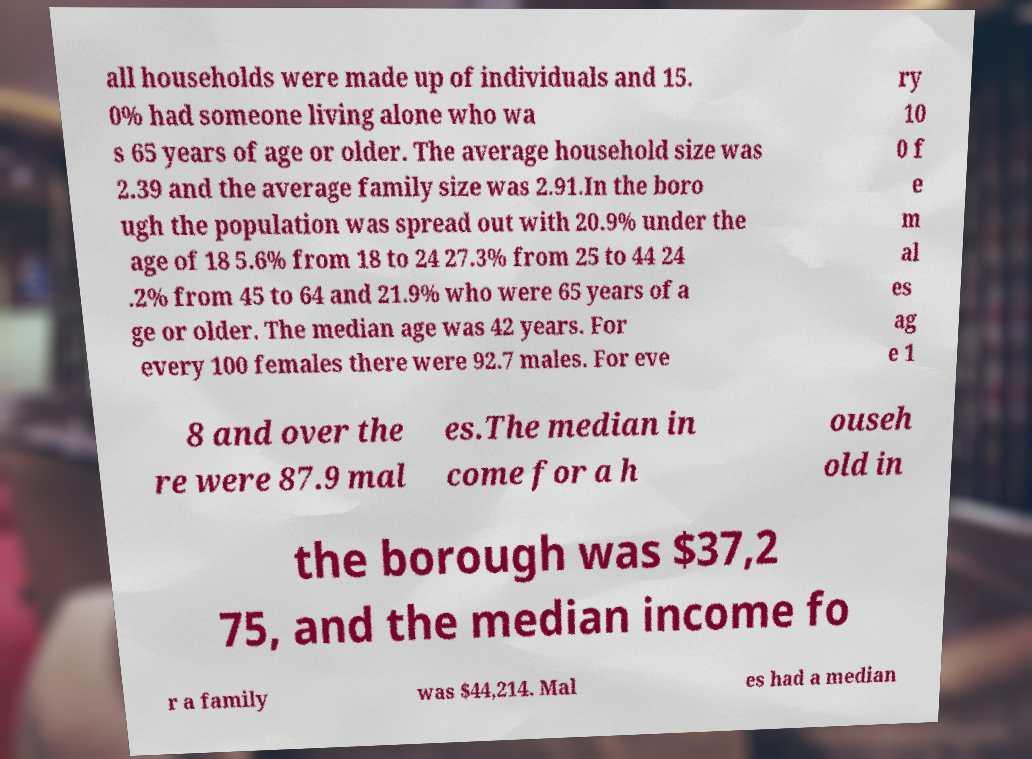Please read and relay the text visible in this image. What does it say? all households were made up of individuals and 15. 0% had someone living alone who wa s 65 years of age or older. The average household size was 2.39 and the average family size was 2.91.In the boro ugh the population was spread out with 20.9% under the age of 18 5.6% from 18 to 24 27.3% from 25 to 44 24 .2% from 45 to 64 and 21.9% who were 65 years of a ge or older. The median age was 42 years. For every 100 females there were 92.7 males. For eve ry 10 0 f e m al es ag e 1 8 and over the re were 87.9 mal es.The median in come for a h ouseh old in the borough was $37,2 75, and the median income fo r a family was $44,214. Mal es had a median 